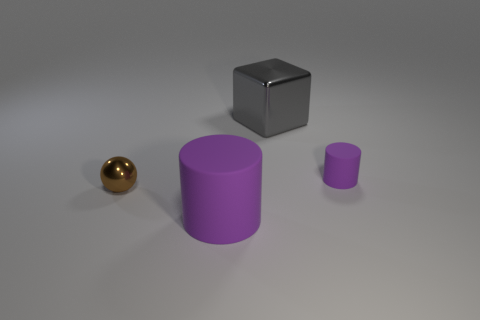Add 1 big gray objects. How many objects exist? 5 Subtract 0 green spheres. How many objects are left? 4 Subtract all cubes. How many objects are left? 3 Subtract 1 cylinders. How many cylinders are left? 1 Subtract all cyan blocks. Subtract all gray balls. How many blocks are left? 1 Subtract all tiny spheres. Subtract all large purple cylinders. How many objects are left? 2 Add 4 brown shiny balls. How many brown shiny balls are left? 5 Add 3 rubber cubes. How many rubber cubes exist? 3 